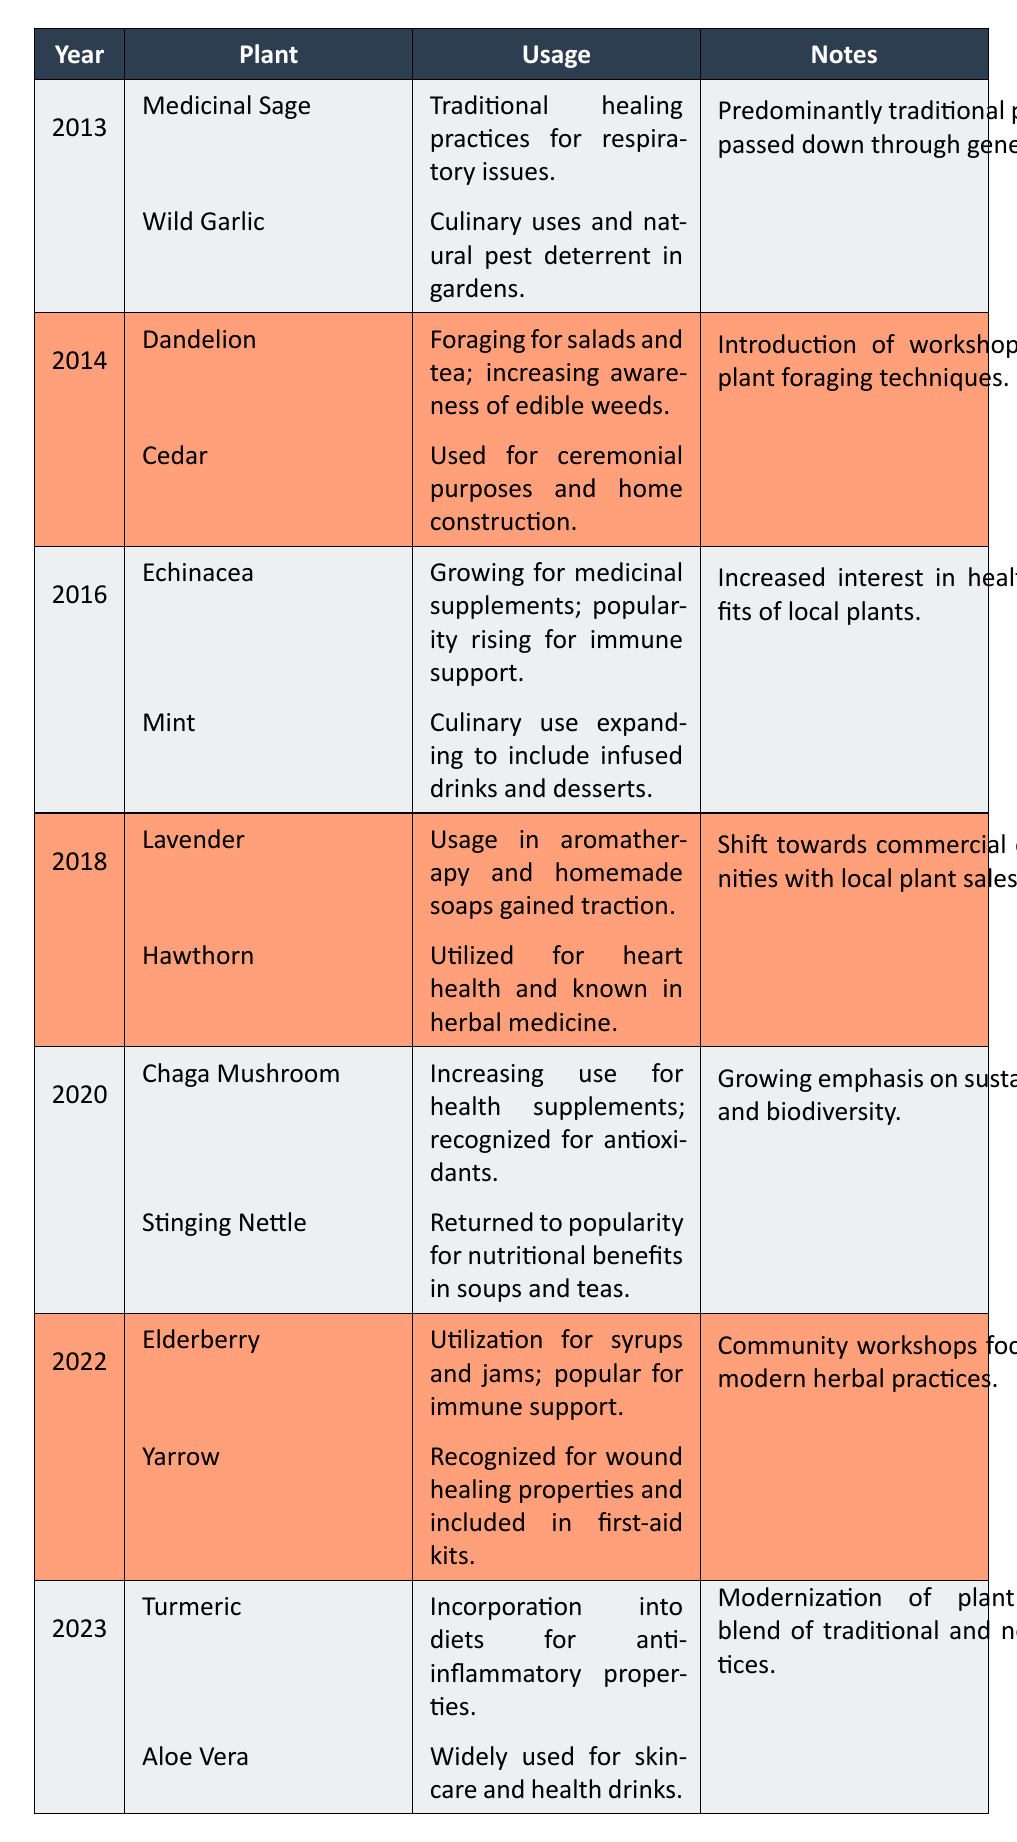What plant was predominantly used for respiratory issues in 2013? The table shows that in 2013, Medicinal Sage was utilized for traditional healing practices for respiratory issues.
Answer: Medicinal Sage What notable plant practice was introduced in 2014? In 2014, the introduction of workshops about plant foraging techniques was a notable practice, showcasing an increased awareness of edible plants.
Answer: Workshops about plant foraging techniques What are the uses of Stinging Nettle according to the table? The table lists that Stinging Nettle returned to popularity for its nutritional benefits in soups and teas in 2020.
Answer: Nutritional benefits in soups and teas Are Elderberry and Yarrow plants used for health benefits in 2022? Yes, according to the table, Elderberry was utilized for syrups and jams especially for immune support, and Yarrow was recognized for its wound healing properties.
Answer: Yes In which year did Echinacea start gaining popularity for immune support? The table indicates that Echinacea began gaining popularity for immune support in 2016, as it was being grown for medicinal supplements.
Answer: 2016 How many plants were listed in the year 2018, and what were their uses? The table lists two plants for 2018: Lavender, used in aromatherapy and homemade soaps, and Hawthorn, utilized for heart health in herbal medicine.
Answer: Two plants: Lavender and Hawthorn Which plant increased in usage for health supplements in 2020, and what was its recognized benefit? The table shows that Chaga Mushroom increased in usage for health supplements in 2020 and was recognized for its antioxidants.
Answer: Chaga Mushroom; antioxidants Was usage of culinary plants increasing over the years according to the table? Yes, the table suggests that there has been an increasing trend in the culinary uses of various plants, such as Mint in 2016 and Aloe Vera in 2023.
Answer: Yes List the plants used in 2023 along with their respective uses. The table states that in 2023, Turmeric was incorporated into diets for its anti-inflammatory properties and Aloe Vera was widely used for skincare and health drinks.
Answer: Turmeric and Aloe Vera What shift in practices was observed in 2022 regarding the community workshops? The table indicates that in 2022, community workshops focused on modern herbal practices, showcasing a shift from solely traditional methods to contemporary approaches.
Answer: Focus on modern herbal practices 